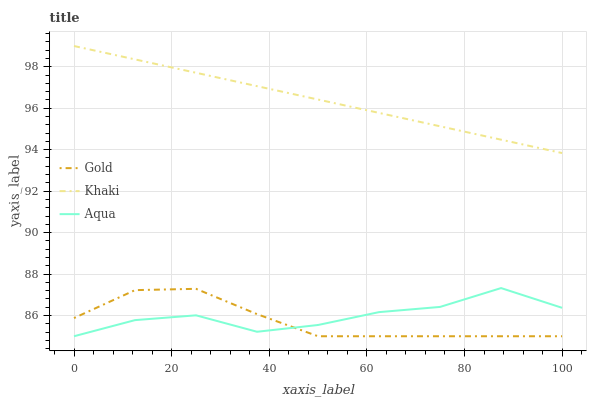Does Gold have the minimum area under the curve?
Answer yes or no. Yes. Does Khaki have the maximum area under the curve?
Answer yes or no. Yes. Does Aqua have the minimum area under the curve?
Answer yes or no. No. Does Aqua have the maximum area under the curve?
Answer yes or no. No. Is Khaki the smoothest?
Answer yes or no. Yes. Is Aqua the roughest?
Answer yes or no. Yes. Is Gold the smoothest?
Answer yes or no. No. Is Gold the roughest?
Answer yes or no. No. Does Aqua have the lowest value?
Answer yes or no. Yes. Does Khaki have the highest value?
Answer yes or no. Yes. Does Aqua have the highest value?
Answer yes or no. No. Is Gold less than Khaki?
Answer yes or no. Yes. Is Khaki greater than Gold?
Answer yes or no. Yes. Does Gold intersect Aqua?
Answer yes or no. Yes. Is Gold less than Aqua?
Answer yes or no. No. Is Gold greater than Aqua?
Answer yes or no. No. Does Gold intersect Khaki?
Answer yes or no. No. 